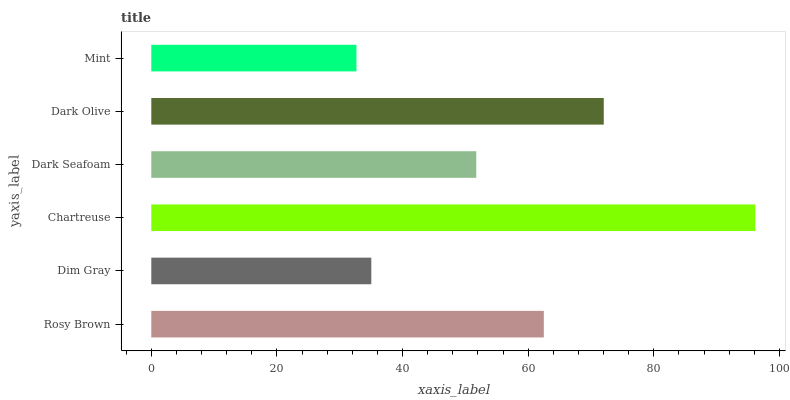Is Mint the minimum?
Answer yes or no. Yes. Is Chartreuse the maximum?
Answer yes or no. Yes. Is Dim Gray the minimum?
Answer yes or no. No. Is Dim Gray the maximum?
Answer yes or no. No. Is Rosy Brown greater than Dim Gray?
Answer yes or no. Yes. Is Dim Gray less than Rosy Brown?
Answer yes or no. Yes. Is Dim Gray greater than Rosy Brown?
Answer yes or no. No. Is Rosy Brown less than Dim Gray?
Answer yes or no. No. Is Rosy Brown the high median?
Answer yes or no. Yes. Is Dark Seafoam the low median?
Answer yes or no. Yes. Is Dark Olive the high median?
Answer yes or no. No. Is Mint the low median?
Answer yes or no. No. 